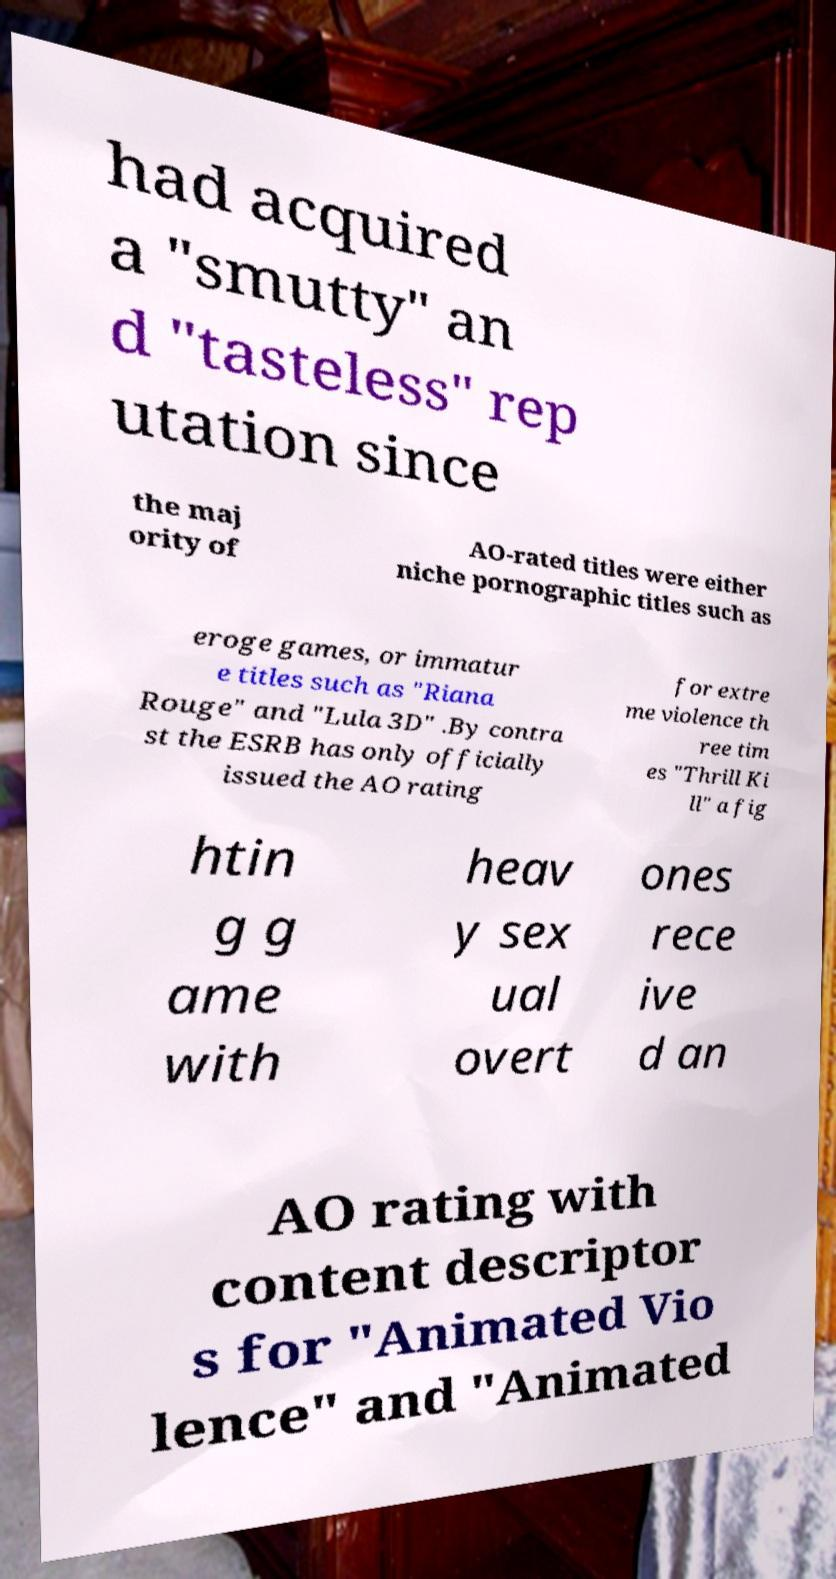Can you accurately transcribe the text from the provided image for me? had acquired a "smutty" an d "tasteless" rep utation since the maj ority of AO-rated titles were either niche pornographic titles such as eroge games, or immatur e titles such as "Riana Rouge" and "Lula 3D" .By contra st the ESRB has only officially issued the AO rating for extre me violence th ree tim es "Thrill Ki ll" a fig htin g g ame with heav y sex ual overt ones rece ive d an AO rating with content descriptor s for "Animated Vio lence" and "Animated 